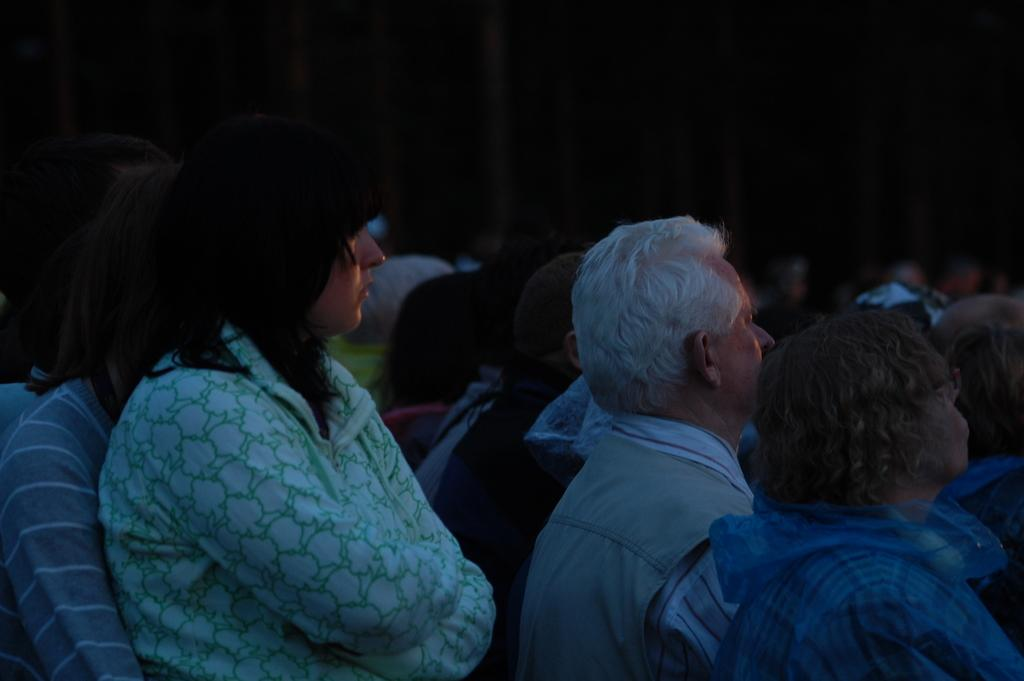How many people are in the image? There are people in the image, but the exact number is not specified. Where are the people located in the image? The people are sitting in the center of the image. What type of art is being created by the people in the image? There is no indication of any art being created in the image; the people are simply sitting. What achievements are the people in the image celebrating? There is no information about any achievements being celebrated in the image; the people are simply sitting. 